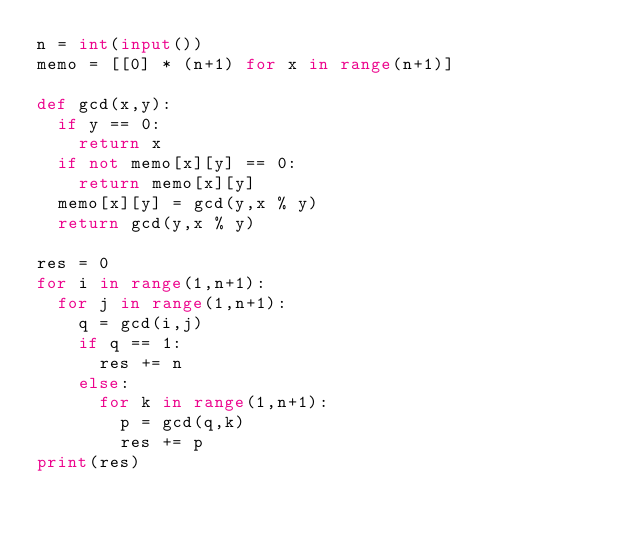<code> <loc_0><loc_0><loc_500><loc_500><_Python_>n = int(input())
memo = [[0] * (n+1) for x in range(n+1)]

def gcd(x,y):
  if y == 0:
    return x
  if not memo[x][y] == 0:
    return memo[x][y]
  memo[x][y] = gcd(y,x % y)
  return gcd(y,x % y)

res = 0
for i in range(1,n+1):
  for j in range(1,n+1):
    q = gcd(i,j)
    if q == 1:
      res += n
    else:
      for k in range(1,n+1):
        p = gcd(q,k)
        res += p
print(res)</code> 